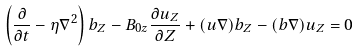Convert formula to latex. <formula><loc_0><loc_0><loc_500><loc_500>\left ( \frac { \partial } { \partial t } - \eta \nabla ^ { 2 } \right ) b _ { Z } - B _ { 0 z } \frac { \partial u _ { Z } } { \partial Z } + ( { u } \nabla ) b _ { Z } - ( { b } \nabla ) u _ { Z } = 0</formula> 